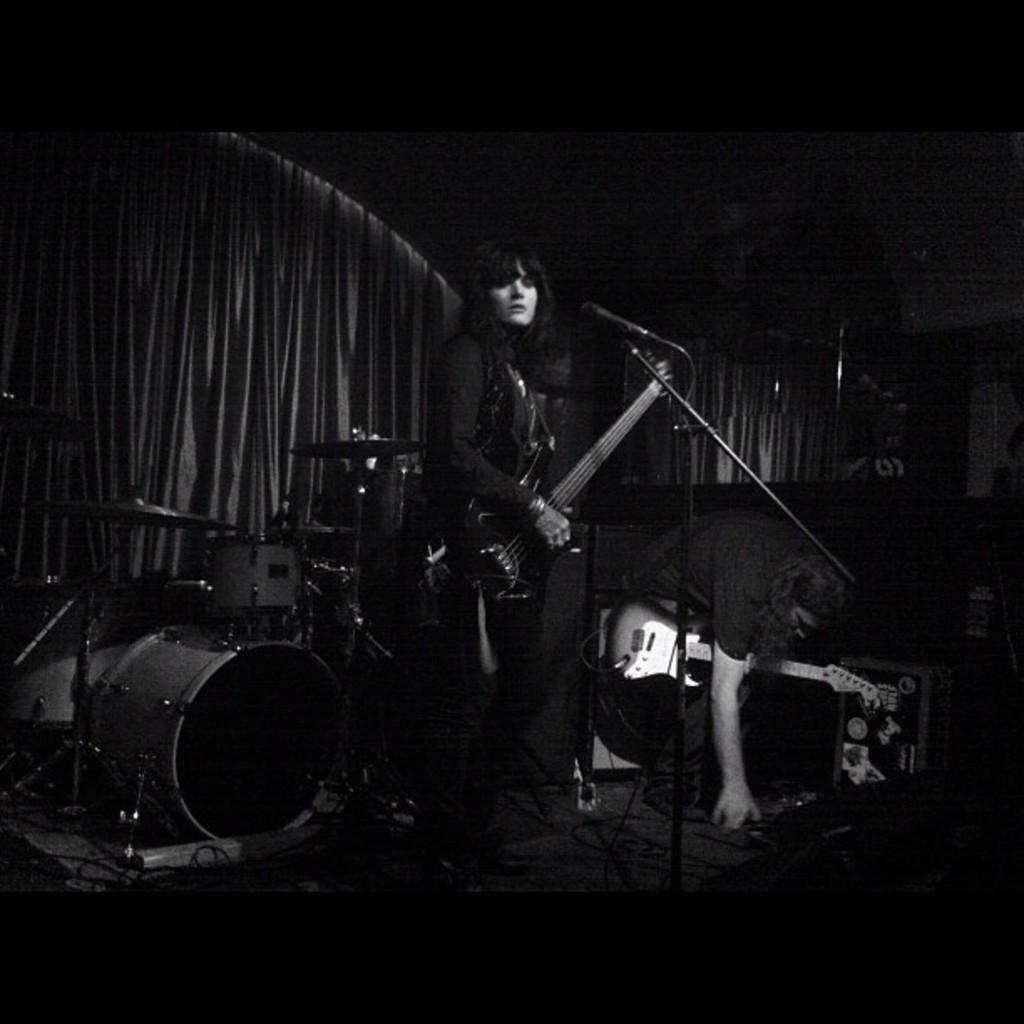How would you summarize this image in a sentence or two? There is a woman standing on the stage and she is playing a guitar. Here we can see a man picking something from the stage. In the background we can see a snare drum musical arrangement. 